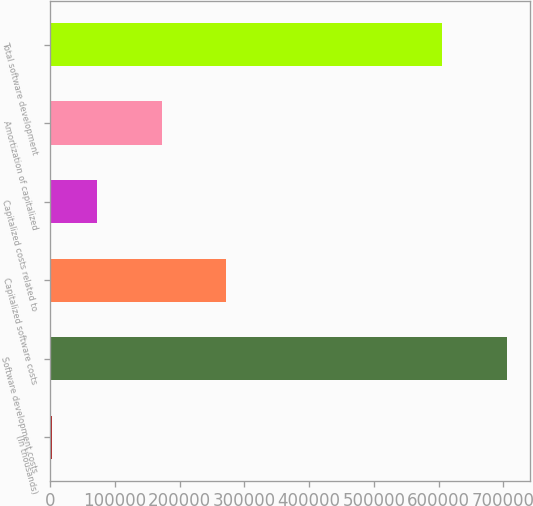Convert chart to OTSL. <chart><loc_0><loc_0><loc_500><loc_500><bar_chart><fcel>(In thousands)<fcel>Software development costs<fcel>Capitalized software costs<fcel>Capitalized costs related to<fcel>Amortization of capitalized<fcel>Total software development<nl><fcel>2017<fcel>705944<fcel>271411<fcel>72409.7<fcel>173250<fcel>605046<nl></chart> 